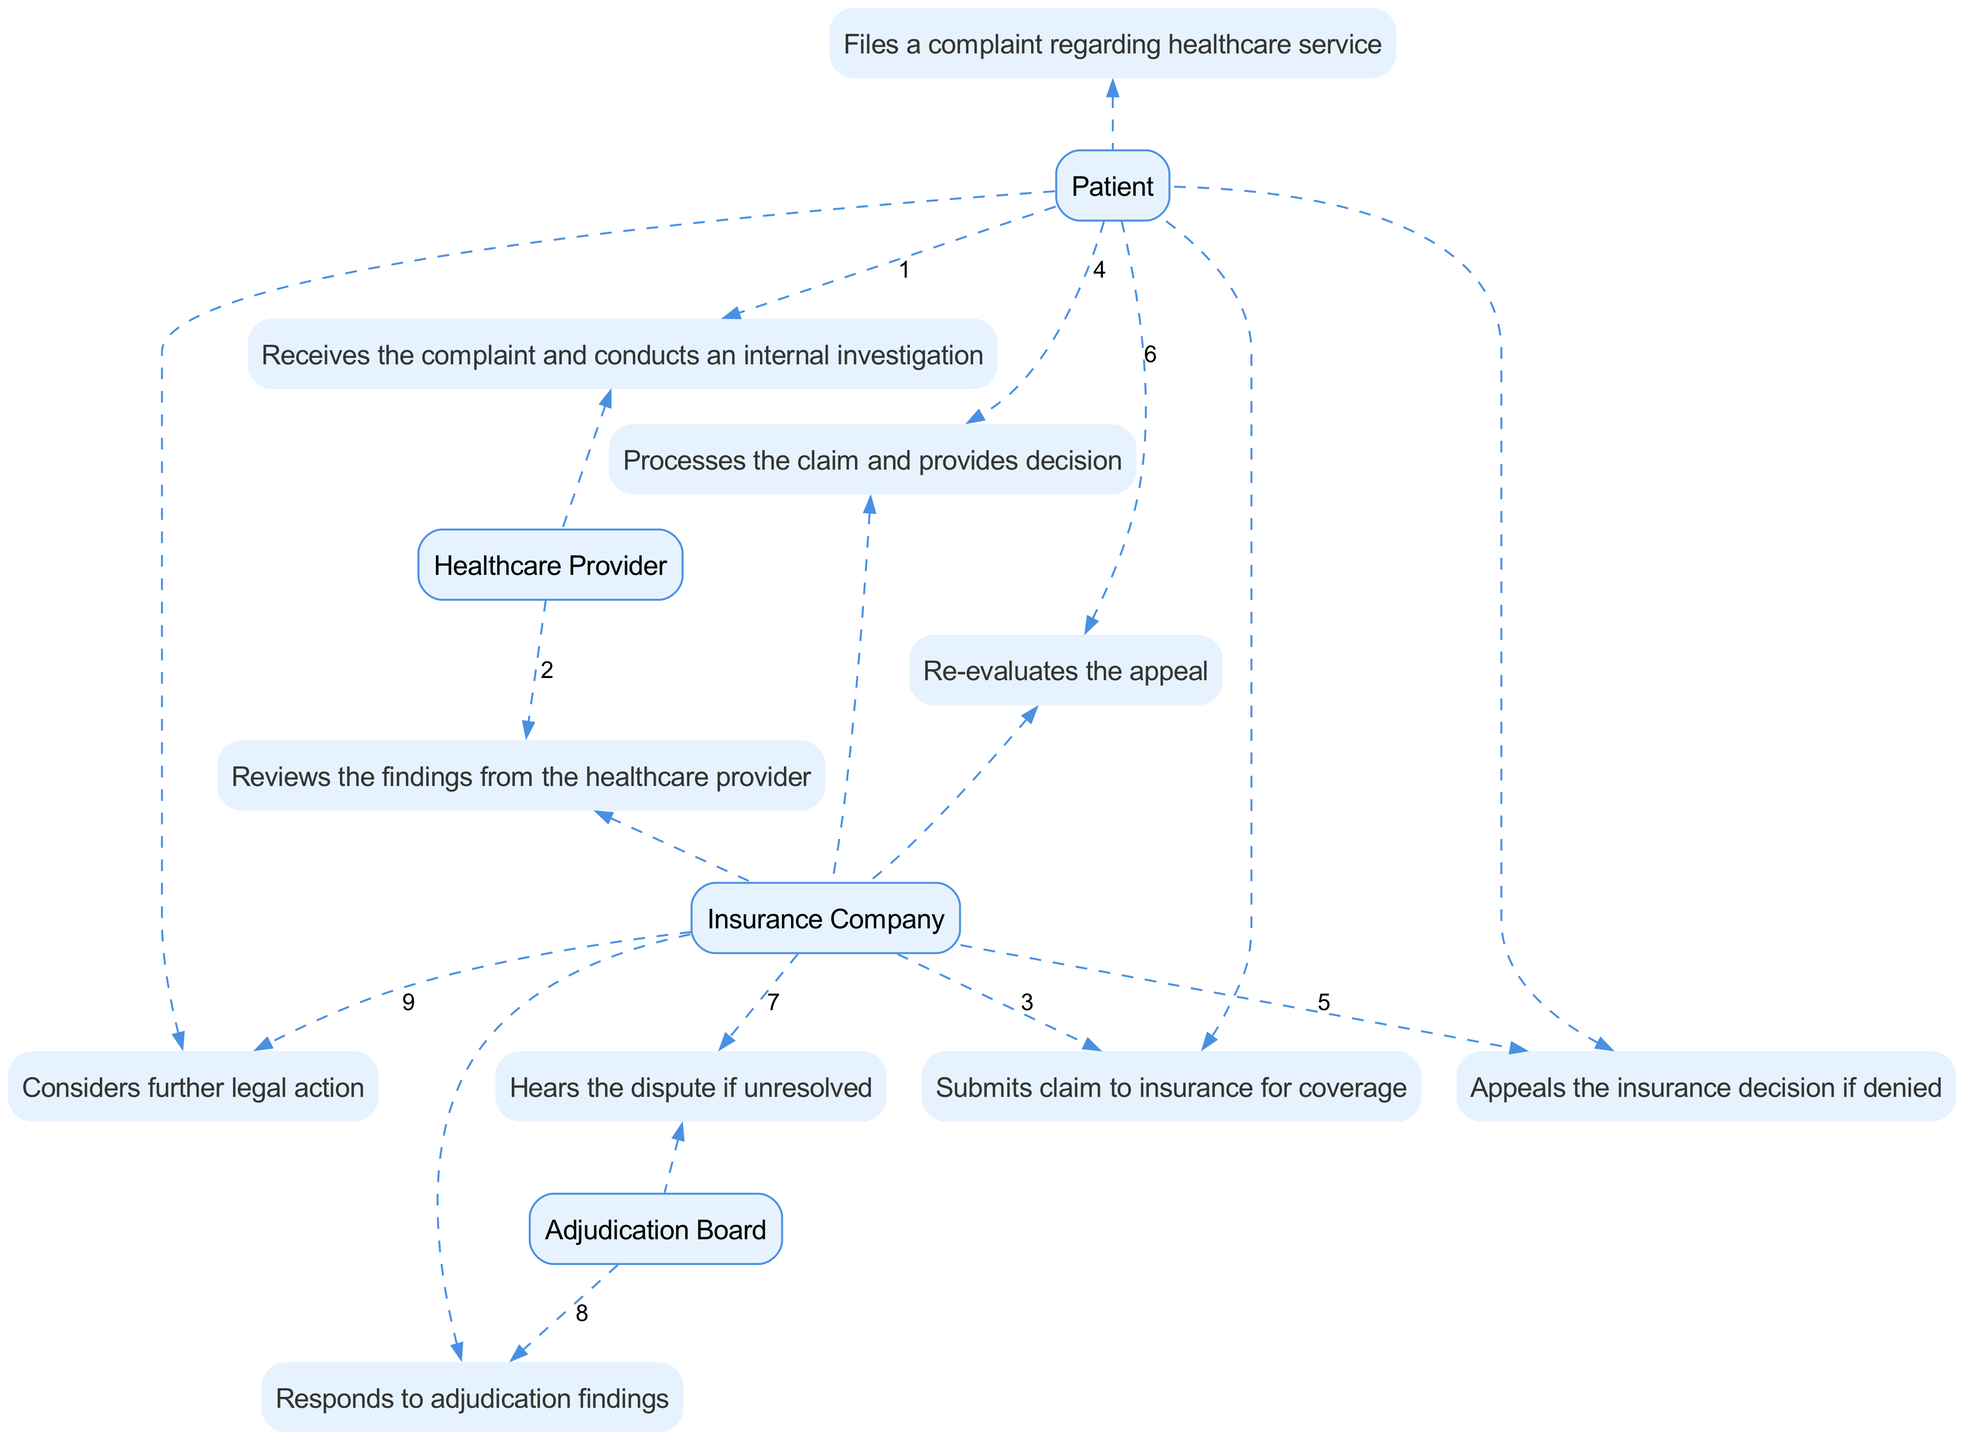What is the first action taken in the sequence? The first action in the sequence is by the Patient who files a complaint regarding healthcare service.
Answer: Files a complaint regarding healthcare service How many entities are involved in the diagram? The entities involved in the diagram are Patient, Healthcare Provider, Insurance Company, and Adjudication Board, totaling to four unique entities.
Answer: Four Who reviews the findings from the healthcare provider? The Insurance Company is the entity that reviews the findings from the healthcare provider after receiving the complaint.
Answer: Insurance Company What action does the Patient take after the Insurance Company processes the claim? After the Insurance Company processes the claim, the Patient appeals the insurance decision if it is denied.
Answer: Appeals the insurance decision if denied Which entity responds to adjudication findings? The Insurance Company is responsible for responding to the adjudication findings, indicating its role in the dispute process.
Answer: Insurance Company What happens if the dispute remains unresolved after the appeal? If the dispute remains unresolved, it is heard by the Adjudication Board to reach a conclusion.
Answer: Hears the dispute if unresolved What is the last action in the sequence? The last action in the sequence is taken by the Patient who considers further legal action if the dispute is not resolved in their favor.
Answer: Considers further legal action How many steps involve the Insurance Company? The Insurance Company appears in four different steps throughout the sequence, indicating its significant role in the process.
Answer: Four Which action occurs immediately after the Patient submits a claim to insurance? The action that occurs immediately after the Patient submits a claim is that the Insurance Company processes the claim and provides a decision.
Answer: Processes the claim and provides decision 